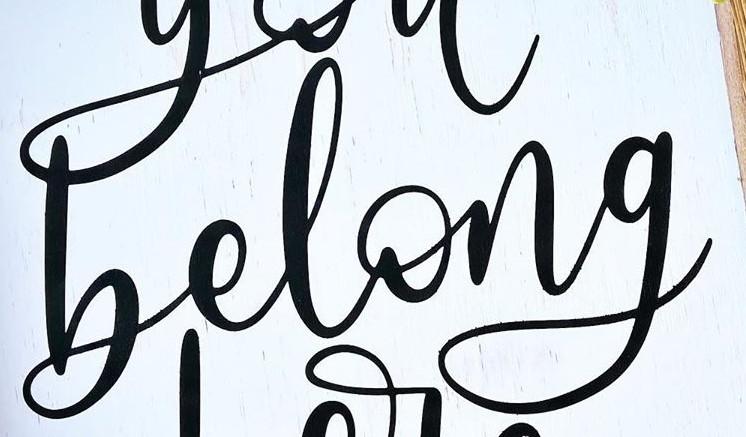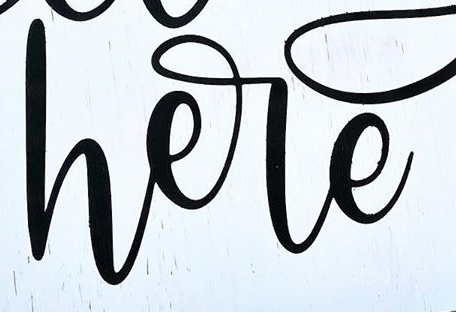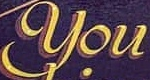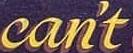What text is displayed in these images sequentially, separated by a semicolon? belong; here; You; can't 